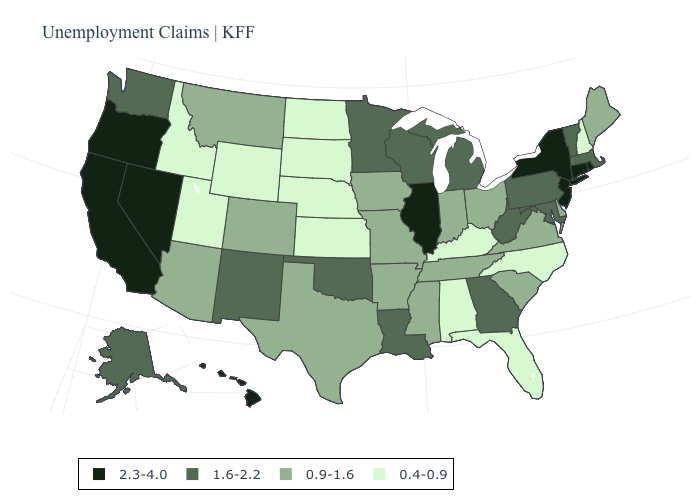What is the value of Alaska?
Short answer required. 1.6-2.2. Among the states that border Vermont , which have the highest value?
Keep it brief. New York. Among the states that border Wisconsin , which have the lowest value?
Give a very brief answer. Iowa. Does Louisiana have a lower value than Nevada?
Be succinct. Yes. What is the lowest value in the USA?
Short answer required. 0.4-0.9. Name the states that have a value in the range 0.4-0.9?
Write a very short answer. Alabama, Florida, Idaho, Kansas, Kentucky, Nebraska, New Hampshire, North Carolina, North Dakota, South Dakota, Utah, Wyoming. Does Alaska have the same value as Idaho?
Be succinct. No. Among the states that border South Dakota , which have the lowest value?
Answer briefly. Nebraska, North Dakota, Wyoming. Does Connecticut have the same value as Oregon?
Short answer required. Yes. Which states have the lowest value in the MidWest?
Short answer required. Kansas, Nebraska, North Dakota, South Dakota. What is the highest value in states that border Vermont?
Keep it brief. 2.3-4.0. Is the legend a continuous bar?
Write a very short answer. No. Which states have the highest value in the USA?
Give a very brief answer. California, Connecticut, Hawaii, Illinois, Nevada, New Jersey, New York, Oregon, Rhode Island. What is the lowest value in the USA?
Keep it brief. 0.4-0.9. Among the states that border New Hampshire , which have the lowest value?
Keep it brief. Maine. 